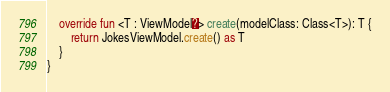Convert code to text. <code><loc_0><loc_0><loc_500><loc_500><_Kotlin_>    override fun <T : ViewModel?> create(modelClass: Class<T>): T {
        return JokesViewModel.create() as T
    }
}</code> 